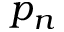<formula> <loc_0><loc_0><loc_500><loc_500>p _ { n }</formula> 